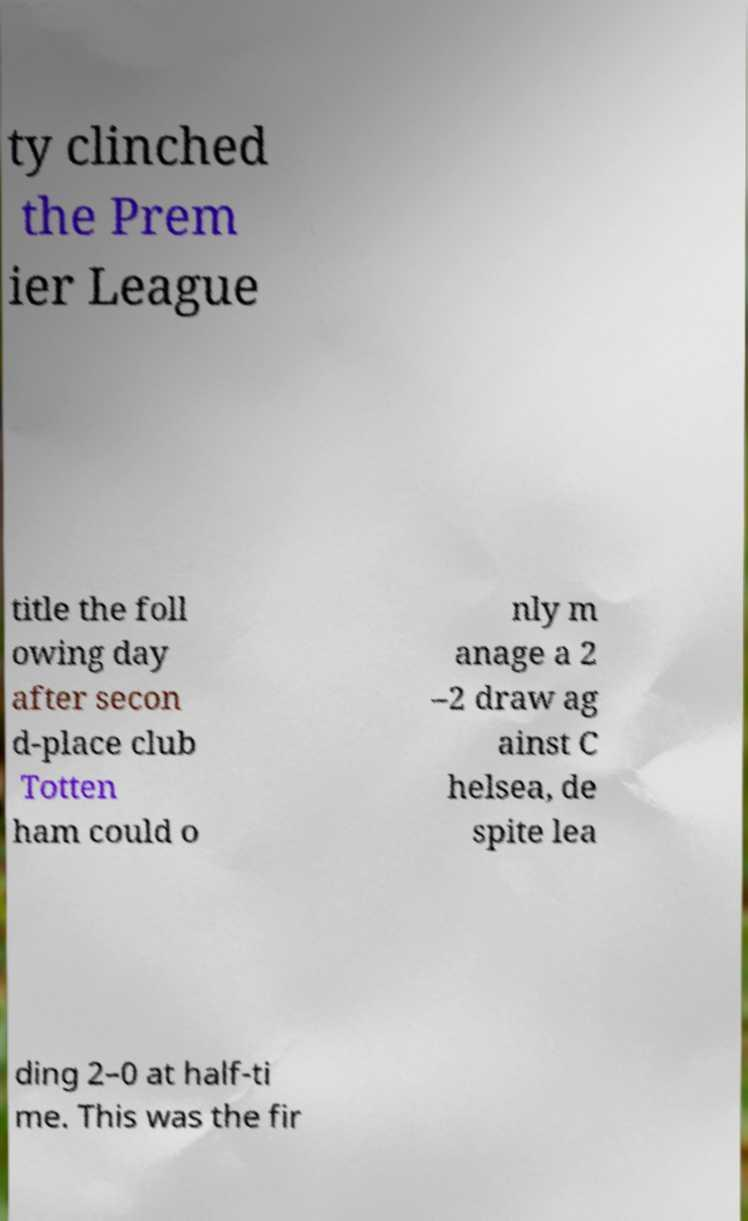For documentation purposes, I need the text within this image transcribed. Could you provide that? ty clinched the Prem ier League title the foll owing day after secon d-place club Totten ham could o nly m anage a 2 –2 draw ag ainst C helsea, de spite lea ding 2–0 at half-ti me. This was the fir 